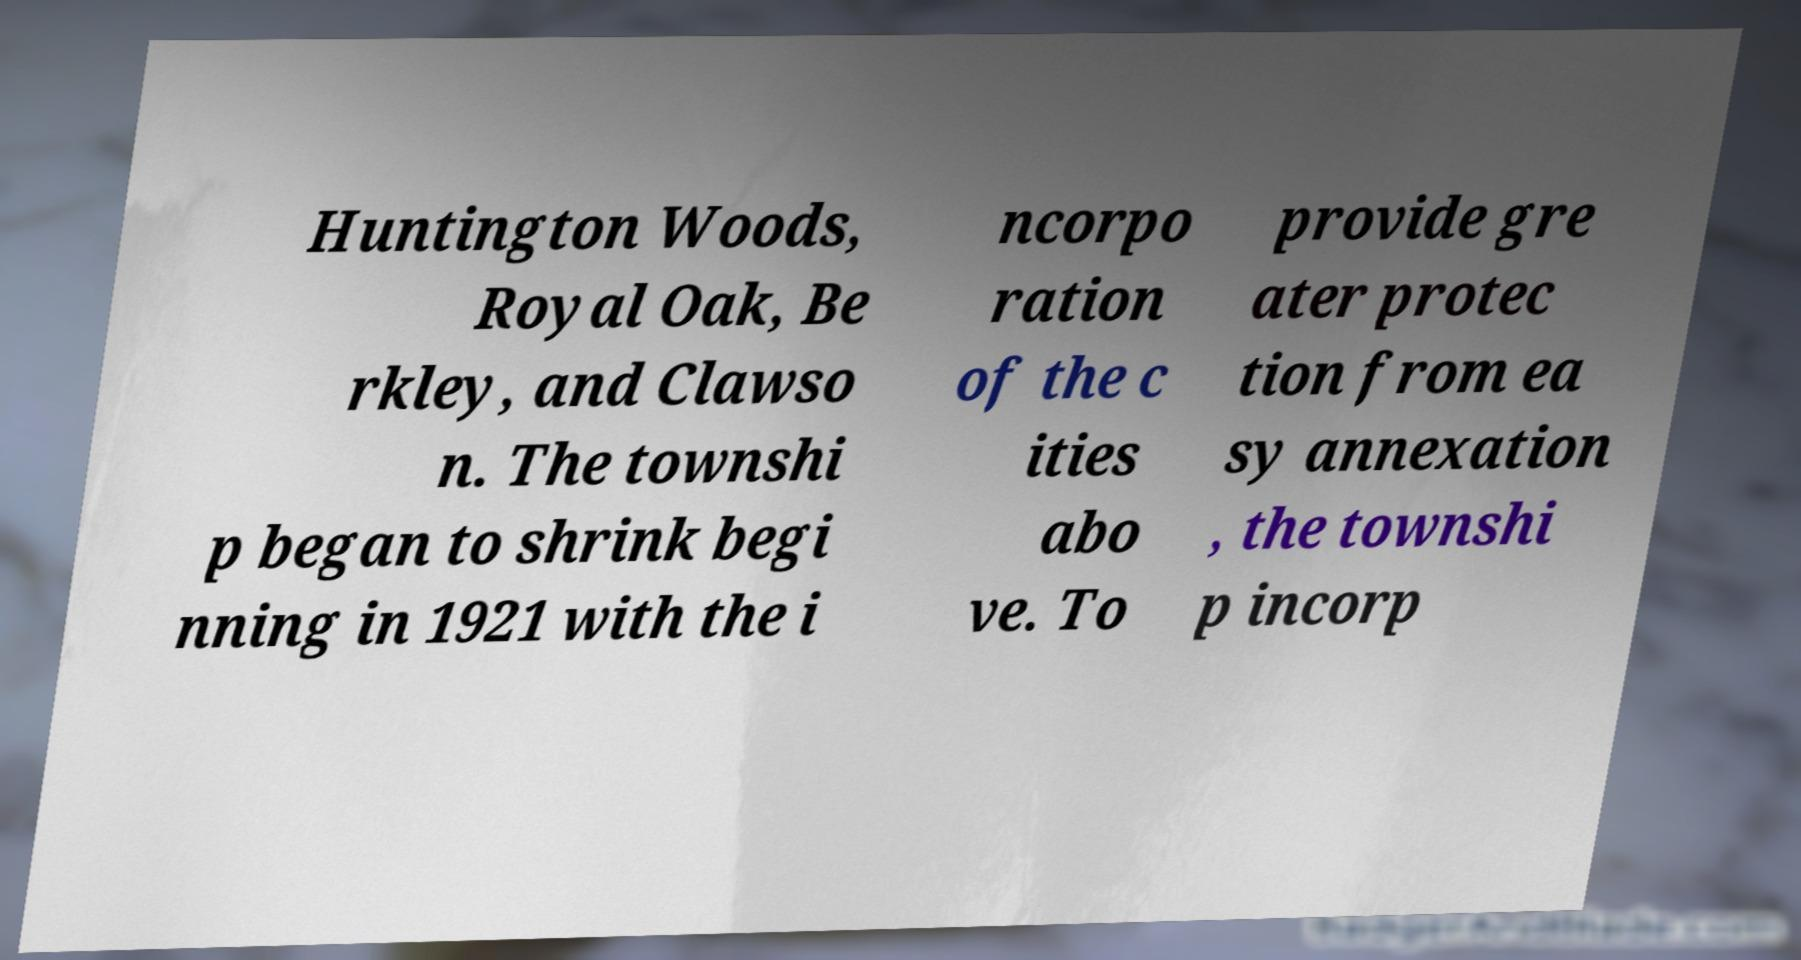What messages or text are displayed in this image? I need them in a readable, typed format. Huntington Woods, Royal Oak, Be rkley, and Clawso n. The townshi p began to shrink begi nning in 1921 with the i ncorpo ration of the c ities abo ve. To provide gre ater protec tion from ea sy annexation , the townshi p incorp 